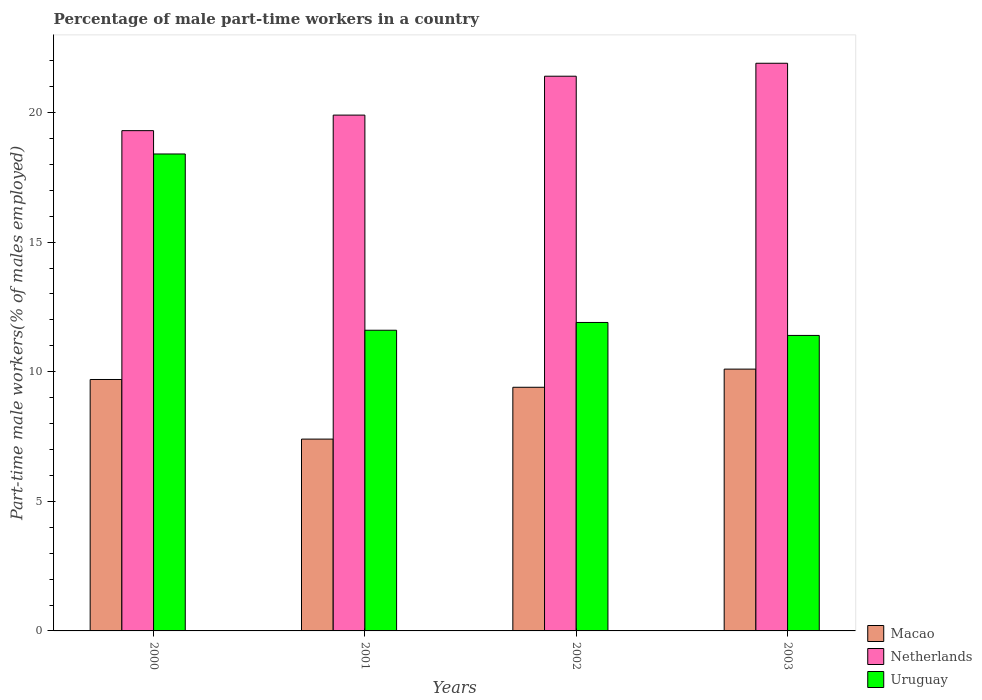How many different coloured bars are there?
Offer a very short reply. 3. How many groups of bars are there?
Provide a succinct answer. 4. Are the number of bars per tick equal to the number of legend labels?
Ensure brevity in your answer.  Yes. How many bars are there on the 4th tick from the right?
Ensure brevity in your answer.  3. In how many cases, is the number of bars for a given year not equal to the number of legend labels?
Provide a short and direct response. 0. What is the percentage of male part-time workers in Uruguay in 2002?
Make the answer very short. 11.9. Across all years, what is the maximum percentage of male part-time workers in Macao?
Keep it short and to the point. 10.1. Across all years, what is the minimum percentage of male part-time workers in Netherlands?
Your answer should be compact. 19.3. In which year was the percentage of male part-time workers in Uruguay maximum?
Your answer should be compact. 2000. In which year was the percentage of male part-time workers in Netherlands minimum?
Keep it short and to the point. 2000. What is the total percentage of male part-time workers in Macao in the graph?
Keep it short and to the point. 36.6. What is the difference between the percentage of male part-time workers in Netherlands in 2000 and the percentage of male part-time workers in Macao in 2001?
Provide a succinct answer. 11.9. What is the average percentage of male part-time workers in Uruguay per year?
Your response must be concise. 13.32. In the year 2001, what is the difference between the percentage of male part-time workers in Uruguay and percentage of male part-time workers in Macao?
Provide a succinct answer. 4.2. In how many years, is the percentage of male part-time workers in Netherlands greater than 2 %?
Your answer should be very brief. 4. What is the ratio of the percentage of male part-time workers in Macao in 2001 to that in 2002?
Your answer should be compact. 0.79. Is the percentage of male part-time workers in Macao in 2000 less than that in 2002?
Your answer should be compact. No. Is the difference between the percentage of male part-time workers in Uruguay in 2001 and 2003 greater than the difference between the percentage of male part-time workers in Macao in 2001 and 2003?
Offer a terse response. Yes. What is the difference between the highest and the second highest percentage of male part-time workers in Macao?
Ensure brevity in your answer.  0.4. What is the difference between the highest and the lowest percentage of male part-time workers in Netherlands?
Offer a very short reply. 2.6. Is the sum of the percentage of male part-time workers in Uruguay in 2001 and 2002 greater than the maximum percentage of male part-time workers in Netherlands across all years?
Your answer should be compact. Yes. What does the 1st bar from the left in 2002 represents?
Your answer should be compact. Macao. What does the 3rd bar from the right in 2001 represents?
Keep it short and to the point. Macao. Is it the case that in every year, the sum of the percentage of male part-time workers in Macao and percentage of male part-time workers in Uruguay is greater than the percentage of male part-time workers in Netherlands?
Your answer should be compact. No. Are all the bars in the graph horizontal?
Ensure brevity in your answer.  No. Does the graph contain any zero values?
Ensure brevity in your answer.  No. Does the graph contain grids?
Provide a short and direct response. No. What is the title of the graph?
Provide a succinct answer. Percentage of male part-time workers in a country. Does "Puerto Rico" appear as one of the legend labels in the graph?
Provide a short and direct response. No. What is the label or title of the X-axis?
Provide a short and direct response. Years. What is the label or title of the Y-axis?
Provide a succinct answer. Part-time male workers(% of males employed). What is the Part-time male workers(% of males employed) of Macao in 2000?
Keep it short and to the point. 9.7. What is the Part-time male workers(% of males employed) of Netherlands in 2000?
Your answer should be compact. 19.3. What is the Part-time male workers(% of males employed) in Uruguay in 2000?
Make the answer very short. 18.4. What is the Part-time male workers(% of males employed) in Macao in 2001?
Provide a succinct answer. 7.4. What is the Part-time male workers(% of males employed) in Netherlands in 2001?
Your answer should be compact. 19.9. What is the Part-time male workers(% of males employed) in Uruguay in 2001?
Keep it short and to the point. 11.6. What is the Part-time male workers(% of males employed) in Macao in 2002?
Your answer should be very brief. 9.4. What is the Part-time male workers(% of males employed) in Netherlands in 2002?
Ensure brevity in your answer.  21.4. What is the Part-time male workers(% of males employed) of Uruguay in 2002?
Ensure brevity in your answer.  11.9. What is the Part-time male workers(% of males employed) of Macao in 2003?
Offer a very short reply. 10.1. What is the Part-time male workers(% of males employed) in Netherlands in 2003?
Offer a terse response. 21.9. What is the Part-time male workers(% of males employed) of Uruguay in 2003?
Ensure brevity in your answer.  11.4. Across all years, what is the maximum Part-time male workers(% of males employed) of Macao?
Ensure brevity in your answer.  10.1. Across all years, what is the maximum Part-time male workers(% of males employed) of Netherlands?
Give a very brief answer. 21.9. Across all years, what is the maximum Part-time male workers(% of males employed) in Uruguay?
Ensure brevity in your answer.  18.4. Across all years, what is the minimum Part-time male workers(% of males employed) of Macao?
Provide a short and direct response. 7.4. Across all years, what is the minimum Part-time male workers(% of males employed) in Netherlands?
Offer a very short reply. 19.3. Across all years, what is the minimum Part-time male workers(% of males employed) in Uruguay?
Provide a short and direct response. 11.4. What is the total Part-time male workers(% of males employed) in Macao in the graph?
Keep it short and to the point. 36.6. What is the total Part-time male workers(% of males employed) in Netherlands in the graph?
Your response must be concise. 82.5. What is the total Part-time male workers(% of males employed) of Uruguay in the graph?
Provide a succinct answer. 53.3. What is the difference between the Part-time male workers(% of males employed) of Netherlands in 2000 and that in 2001?
Give a very brief answer. -0.6. What is the difference between the Part-time male workers(% of males employed) in Macao in 2000 and that in 2002?
Make the answer very short. 0.3. What is the difference between the Part-time male workers(% of males employed) in Uruguay in 2000 and that in 2002?
Your answer should be compact. 6.5. What is the difference between the Part-time male workers(% of males employed) in Macao in 2000 and that in 2003?
Your answer should be compact. -0.4. What is the difference between the Part-time male workers(% of males employed) of Netherlands in 2000 and that in 2003?
Your answer should be compact. -2.6. What is the difference between the Part-time male workers(% of males employed) of Uruguay in 2000 and that in 2003?
Keep it short and to the point. 7. What is the difference between the Part-time male workers(% of males employed) in Macao in 2001 and that in 2002?
Keep it short and to the point. -2. What is the difference between the Part-time male workers(% of males employed) in Netherlands in 2001 and that in 2002?
Give a very brief answer. -1.5. What is the difference between the Part-time male workers(% of males employed) of Uruguay in 2001 and that in 2002?
Your answer should be very brief. -0.3. What is the difference between the Part-time male workers(% of males employed) in Netherlands in 2001 and that in 2003?
Ensure brevity in your answer.  -2. What is the difference between the Part-time male workers(% of males employed) of Uruguay in 2001 and that in 2003?
Offer a very short reply. 0.2. What is the difference between the Part-time male workers(% of males employed) in Macao in 2002 and that in 2003?
Keep it short and to the point. -0.7. What is the difference between the Part-time male workers(% of males employed) of Netherlands in 2000 and the Part-time male workers(% of males employed) of Uruguay in 2002?
Provide a succinct answer. 7.4. What is the difference between the Part-time male workers(% of males employed) of Macao in 2000 and the Part-time male workers(% of males employed) of Netherlands in 2003?
Your answer should be compact. -12.2. What is the difference between the Part-time male workers(% of males employed) of Macao in 2001 and the Part-time male workers(% of males employed) of Uruguay in 2002?
Provide a succinct answer. -4.5. What is the difference between the Part-time male workers(% of males employed) of Netherlands in 2001 and the Part-time male workers(% of males employed) of Uruguay in 2002?
Offer a very short reply. 8. What is the difference between the Part-time male workers(% of males employed) of Macao in 2001 and the Part-time male workers(% of males employed) of Netherlands in 2003?
Give a very brief answer. -14.5. What is the average Part-time male workers(% of males employed) of Macao per year?
Your answer should be compact. 9.15. What is the average Part-time male workers(% of males employed) in Netherlands per year?
Offer a terse response. 20.62. What is the average Part-time male workers(% of males employed) in Uruguay per year?
Offer a terse response. 13.32. In the year 2000, what is the difference between the Part-time male workers(% of males employed) in Macao and Part-time male workers(% of males employed) in Netherlands?
Your response must be concise. -9.6. In the year 2000, what is the difference between the Part-time male workers(% of males employed) of Netherlands and Part-time male workers(% of males employed) of Uruguay?
Provide a short and direct response. 0.9. In the year 2001, what is the difference between the Part-time male workers(% of males employed) in Macao and Part-time male workers(% of males employed) in Uruguay?
Keep it short and to the point. -4.2. In the year 2003, what is the difference between the Part-time male workers(% of males employed) in Macao and Part-time male workers(% of males employed) in Uruguay?
Keep it short and to the point. -1.3. In the year 2003, what is the difference between the Part-time male workers(% of males employed) in Netherlands and Part-time male workers(% of males employed) in Uruguay?
Give a very brief answer. 10.5. What is the ratio of the Part-time male workers(% of males employed) in Macao in 2000 to that in 2001?
Your answer should be compact. 1.31. What is the ratio of the Part-time male workers(% of males employed) of Netherlands in 2000 to that in 2001?
Give a very brief answer. 0.97. What is the ratio of the Part-time male workers(% of males employed) of Uruguay in 2000 to that in 2001?
Keep it short and to the point. 1.59. What is the ratio of the Part-time male workers(% of males employed) in Macao in 2000 to that in 2002?
Provide a short and direct response. 1.03. What is the ratio of the Part-time male workers(% of males employed) in Netherlands in 2000 to that in 2002?
Your answer should be compact. 0.9. What is the ratio of the Part-time male workers(% of males employed) of Uruguay in 2000 to that in 2002?
Give a very brief answer. 1.55. What is the ratio of the Part-time male workers(% of males employed) of Macao in 2000 to that in 2003?
Keep it short and to the point. 0.96. What is the ratio of the Part-time male workers(% of males employed) in Netherlands in 2000 to that in 2003?
Make the answer very short. 0.88. What is the ratio of the Part-time male workers(% of males employed) in Uruguay in 2000 to that in 2003?
Ensure brevity in your answer.  1.61. What is the ratio of the Part-time male workers(% of males employed) in Macao in 2001 to that in 2002?
Keep it short and to the point. 0.79. What is the ratio of the Part-time male workers(% of males employed) of Netherlands in 2001 to that in 2002?
Your response must be concise. 0.93. What is the ratio of the Part-time male workers(% of males employed) of Uruguay in 2001 to that in 2002?
Your answer should be very brief. 0.97. What is the ratio of the Part-time male workers(% of males employed) in Macao in 2001 to that in 2003?
Make the answer very short. 0.73. What is the ratio of the Part-time male workers(% of males employed) in Netherlands in 2001 to that in 2003?
Keep it short and to the point. 0.91. What is the ratio of the Part-time male workers(% of males employed) in Uruguay in 2001 to that in 2003?
Provide a succinct answer. 1.02. What is the ratio of the Part-time male workers(% of males employed) in Macao in 2002 to that in 2003?
Make the answer very short. 0.93. What is the ratio of the Part-time male workers(% of males employed) in Netherlands in 2002 to that in 2003?
Keep it short and to the point. 0.98. What is the ratio of the Part-time male workers(% of males employed) in Uruguay in 2002 to that in 2003?
Your answer should be compact. 1.04. What is the difference between the highest and the second highest Part-time male workers(% of males employed) of Macao?
Ensure brevity in your answer.  0.4. What is the difference between the highest and the second highest Part-time male workers(% of males employed) of Uruguay?
Your answer should be compact. 6.5. What is the difference between the highest and the lowest Part-time male workers(% of males employed) in Macao?
Provide a succinct answer. 2.7. What is the difference between the highest and the lowest Part-time male workers(% of males employed) of Uruguay?
Provide a succinct answer. 7. 